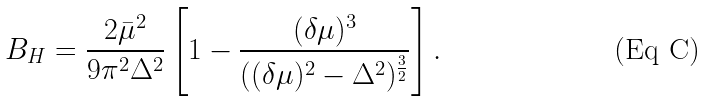<formula> <loc_0><loc_0><loc_500><loc_500>B _ { H } = \frac { 2 \bar { \mu } ^ { 2 } } { 9 \pi ^ { 2 } \Delta ^ { 2 } } \left [ 1 - \frac { ( \delta \mu ) ^ { 3 } } { ( ( \delta \mu ) ^ { 2 } - \Delta ^ { 2 } ) ^ { \frac { 3 } { 2 } } } \right ] .</formula> 